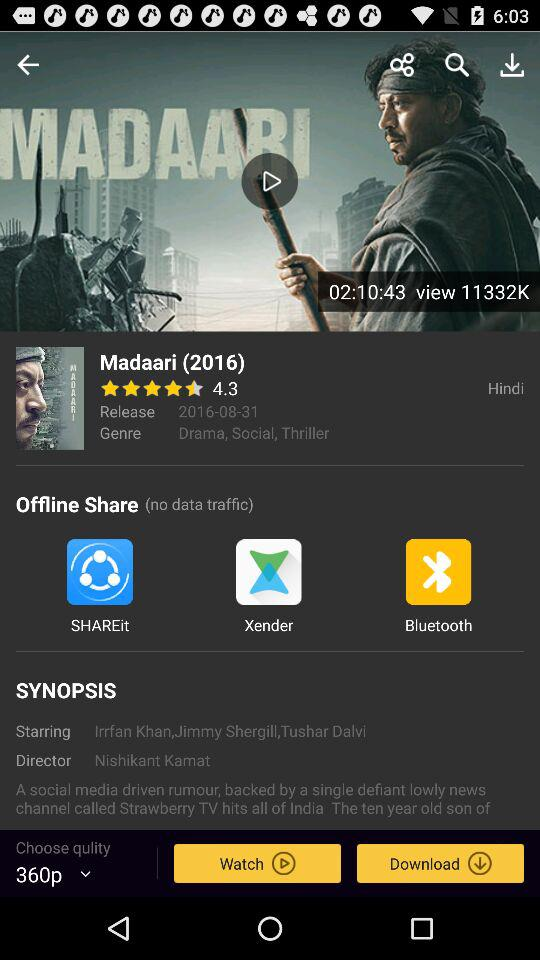Who's the director of "Madaari"? The director of "Madaari" is Nishikant Kamat. 